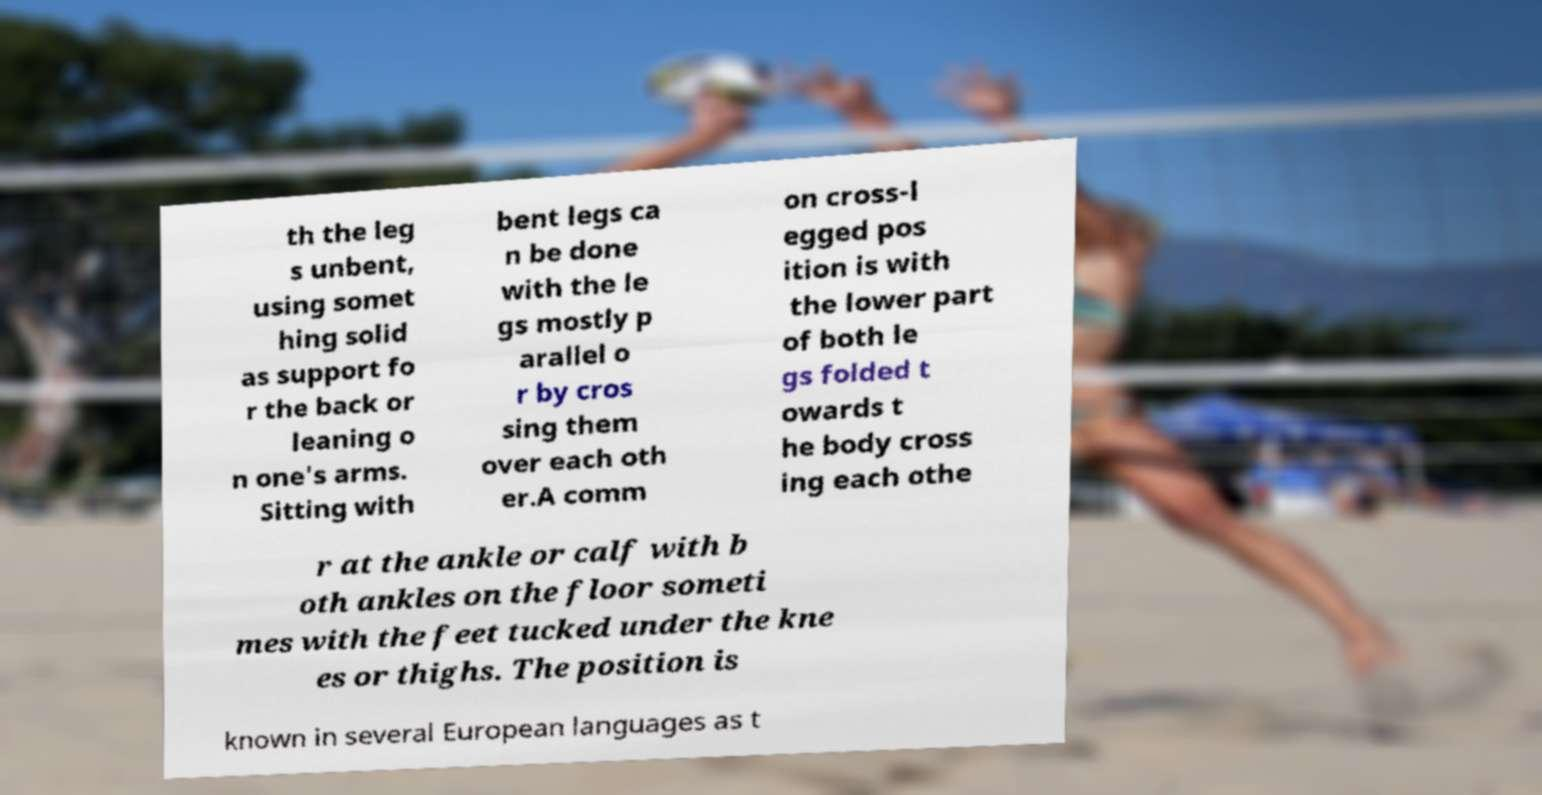Could you extract and type out the text from this image? th the leg s unbent, using somet hing solid as support fo r the back or leaning o n one's arms. Sitting with bent legs ca n be done with the le gs mostly p arallel o r by cros sing them over each oth er.A comm on cross-l egged pos ition is with the lower part of both le gs folded t owards t he body cross ing each othe r at the ankle or calf with b oth ankles on the floor someti mes with the feet tucked under the kne es or thighs. The position is known in several European languages as t 